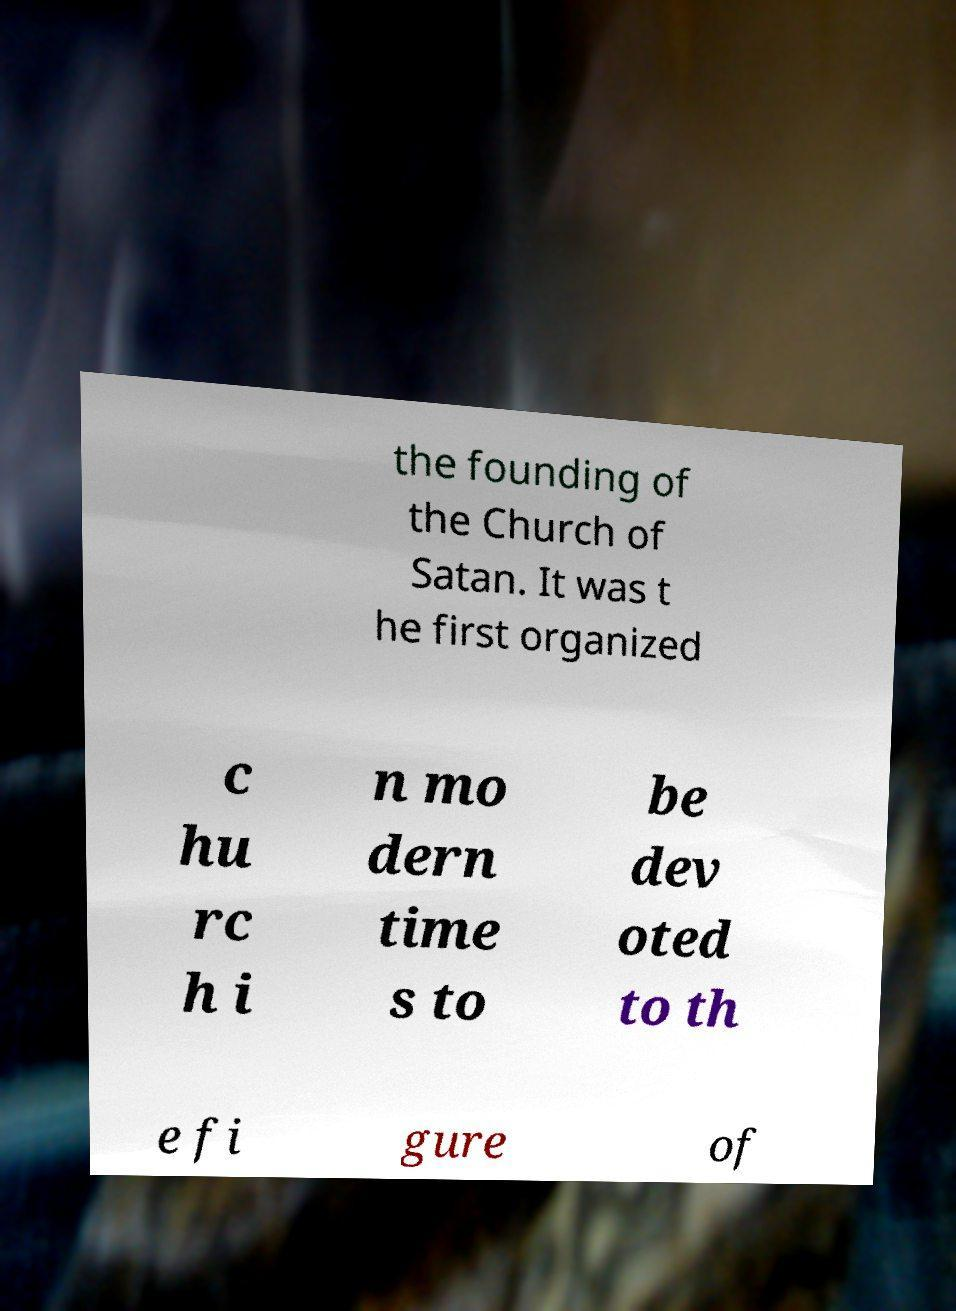What messages or text are displayed in this image? I need them in a readable, typed format. the founding of the Church of Satan. It was t he first organized c hu rc h i n mo dern time s to be dev oted to th e fi gure of 